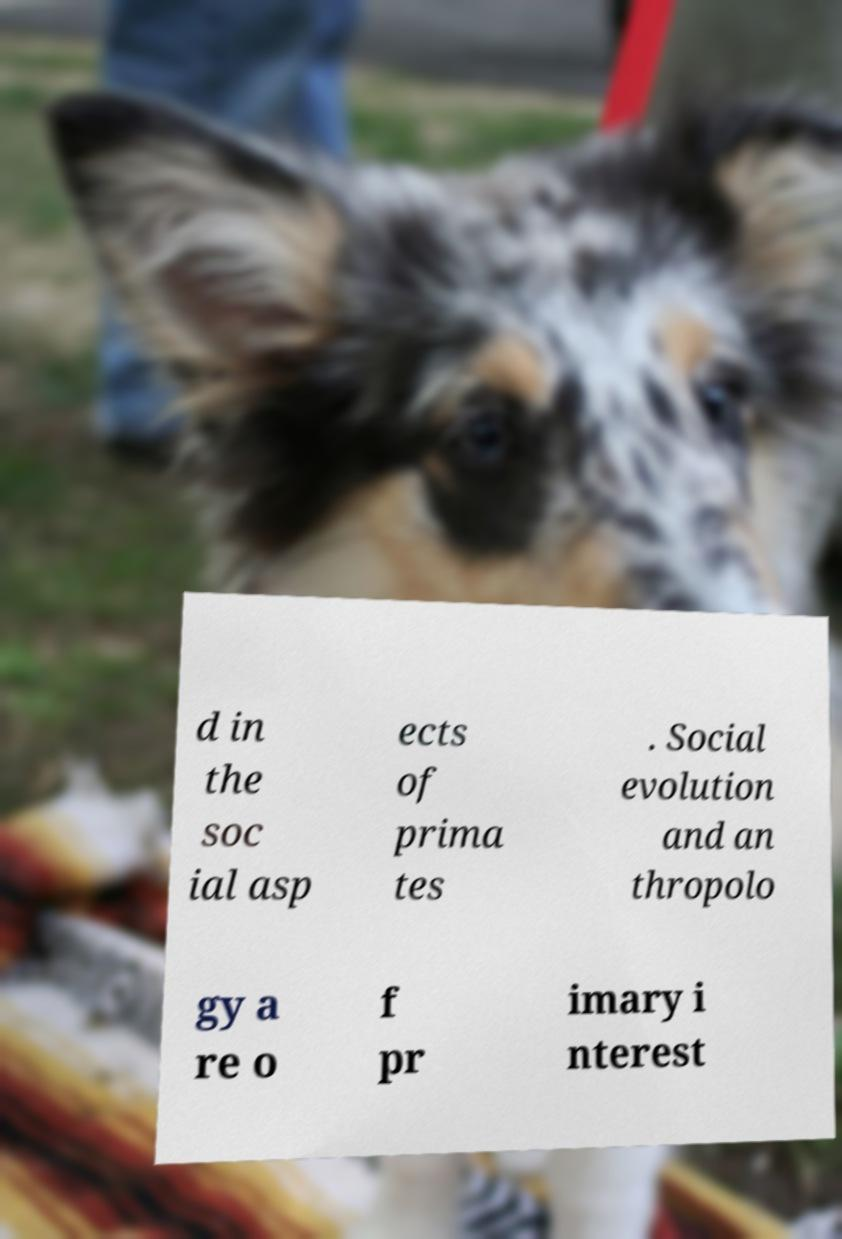Can you read and provide the text displayed in the image?This photo seems to have some interesting text. Can you extract and type it out for me? d in the soc ial asp ects of prima tes . Social evolution and an thropolo gy a re o f pr imary i nterest 